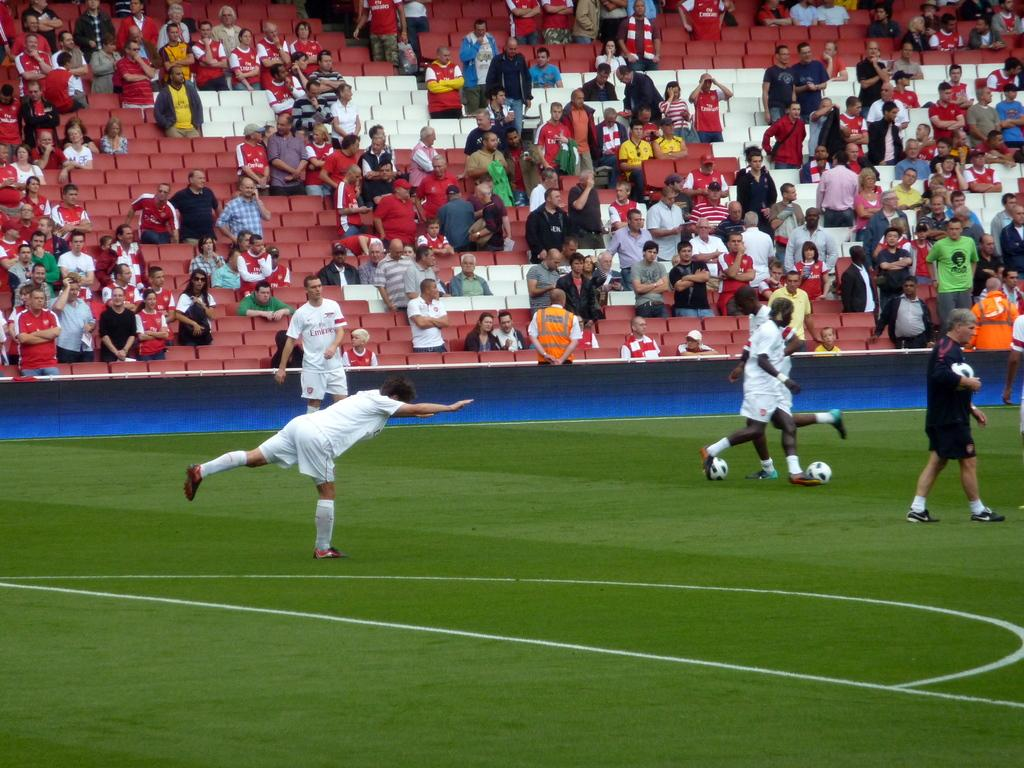<image>
Create a compact narrative representing the image presented. A soccer player stands close to the spectator seating with a jersey displaying a word that start with Em. 